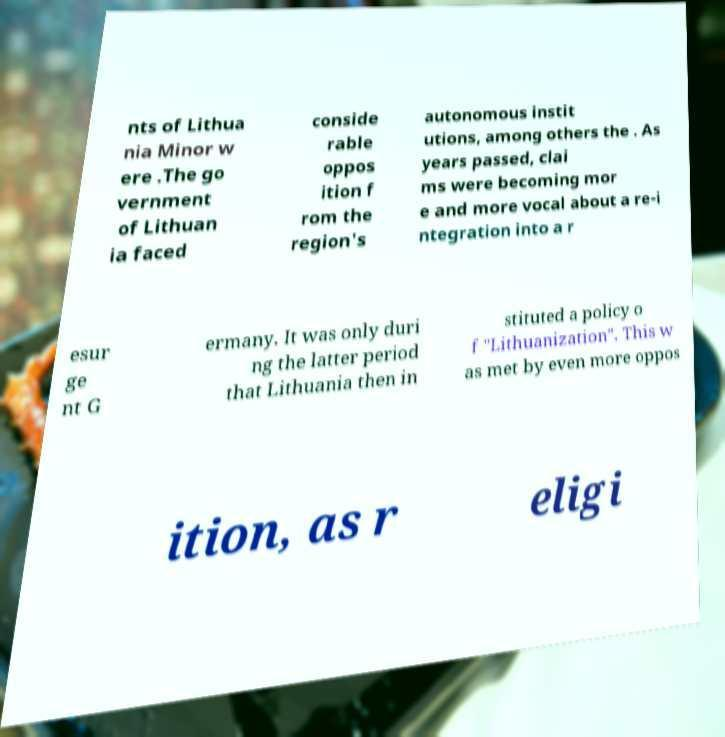What messages or text are displayed in this image? I need them in a readable, typed format. nts of Lithua nia Minor w ere .The go vernment of Lithuan ia faced conside rable oppos ition f rom the region's autonomous instit utions, among others the . As years passed, clai ms were becoming mor e and more vocal about a re-i ntegration into a r esur ge nt G ermany. It was only duri ng the latter period that Lithuania then in stituted a policy o f "Lithuanization". This w as met by even more oppos ition, as r eligi 